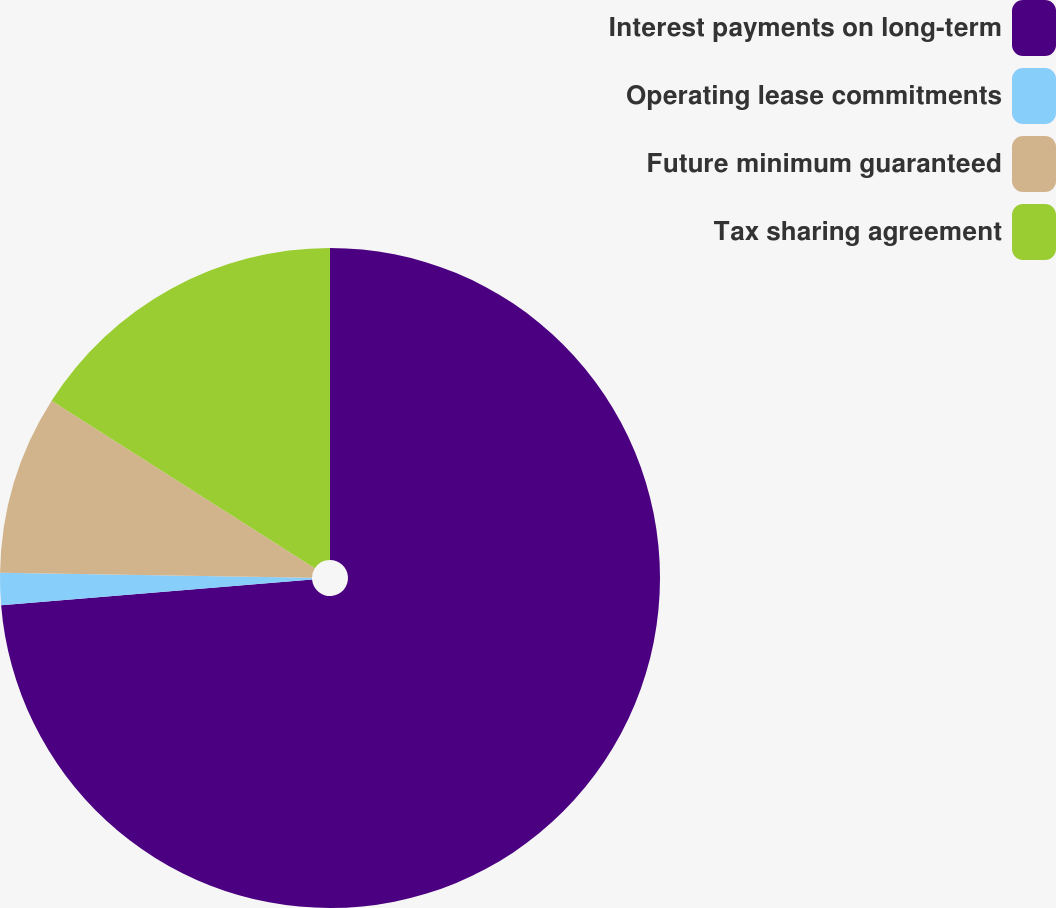<chart> <loc_0><loc_0><loc_500><loc_500><pie_chart><fcel>Interest payments on long-term<fcel>Operating lease commitments<fcel>Future minimum guaranteed<fcel>Tax sharing agreement<nl><fcel>73.69%<fcel>1.56%<fcel>8.77%<fcel>15.98%<nl></chart> 